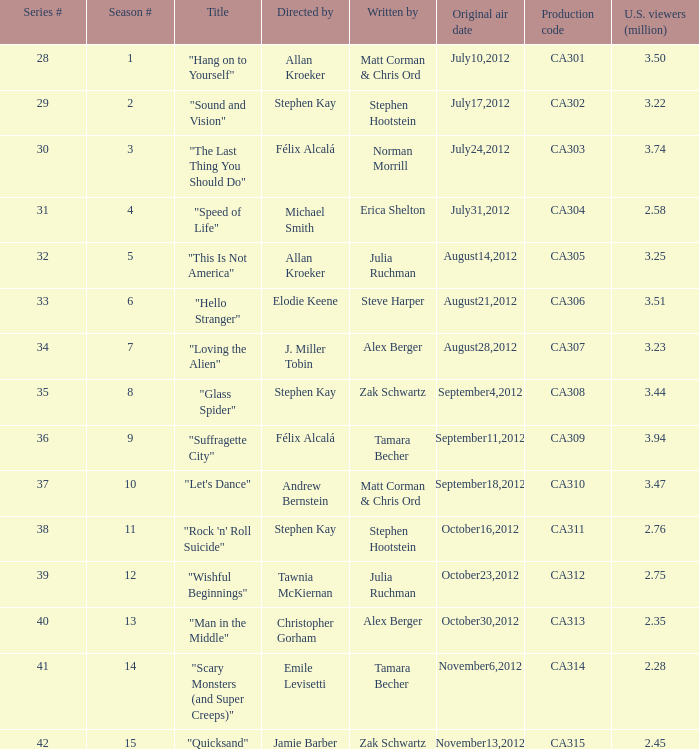75 million watchers in the u.s.? "Wishful Beginnings". 